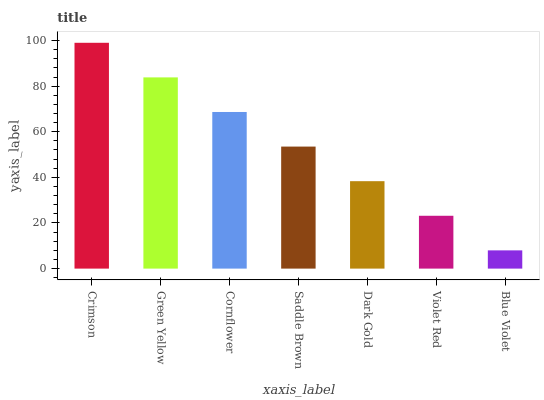Is Blue Violet the minimum?
Answer yes or no. Yes. Is Crimson the maximum?
Answer yes or no. Yes. Is Green Yellow the minimum?
Answer yes or no. No. Is Green Yellow the maximum?
Answer yes or no. No. Is Crimson greater than Green Yellow?
Answer yes or no. Yes. Is Green Yellow less than Crimson?
Answer yes or no. Yes. Is Green Yellow greater than Crimson?
Answer yes or no. No. Is Crimson less than Green Yellow?
Answer yes or no. No. Is Saddle Brown the high median?
Answer yes or no. Yes. Is Saddle Brown the low median?
Answer yes or no. Yes. Is Blue Violet the high median?
Answer yes or no. No. Is Dark Gold the low median?
Answer yes or no. No. 